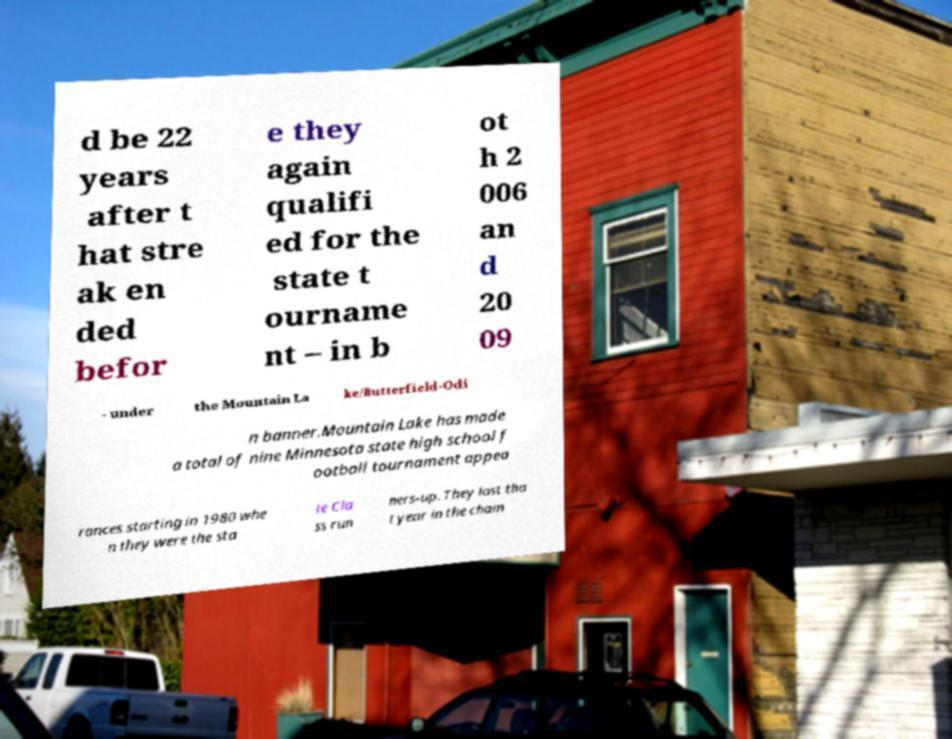Could you assist in decoding the text presented in this image and type it out clearly? d be 22 years after t hat stre ak en ded befor e they again qualifi ed for the state t ourname nt – in b ot h 2 006 an d 20 09 - under the Mountain La ke/Butterfield-Odi n banner.Mountain Lake has made a total of nine Minnesota state high school f ootball tournament appea rances starting in 1980 whe n they were the sta te Cla ss run ners-up. They lost tha t year in the cham 